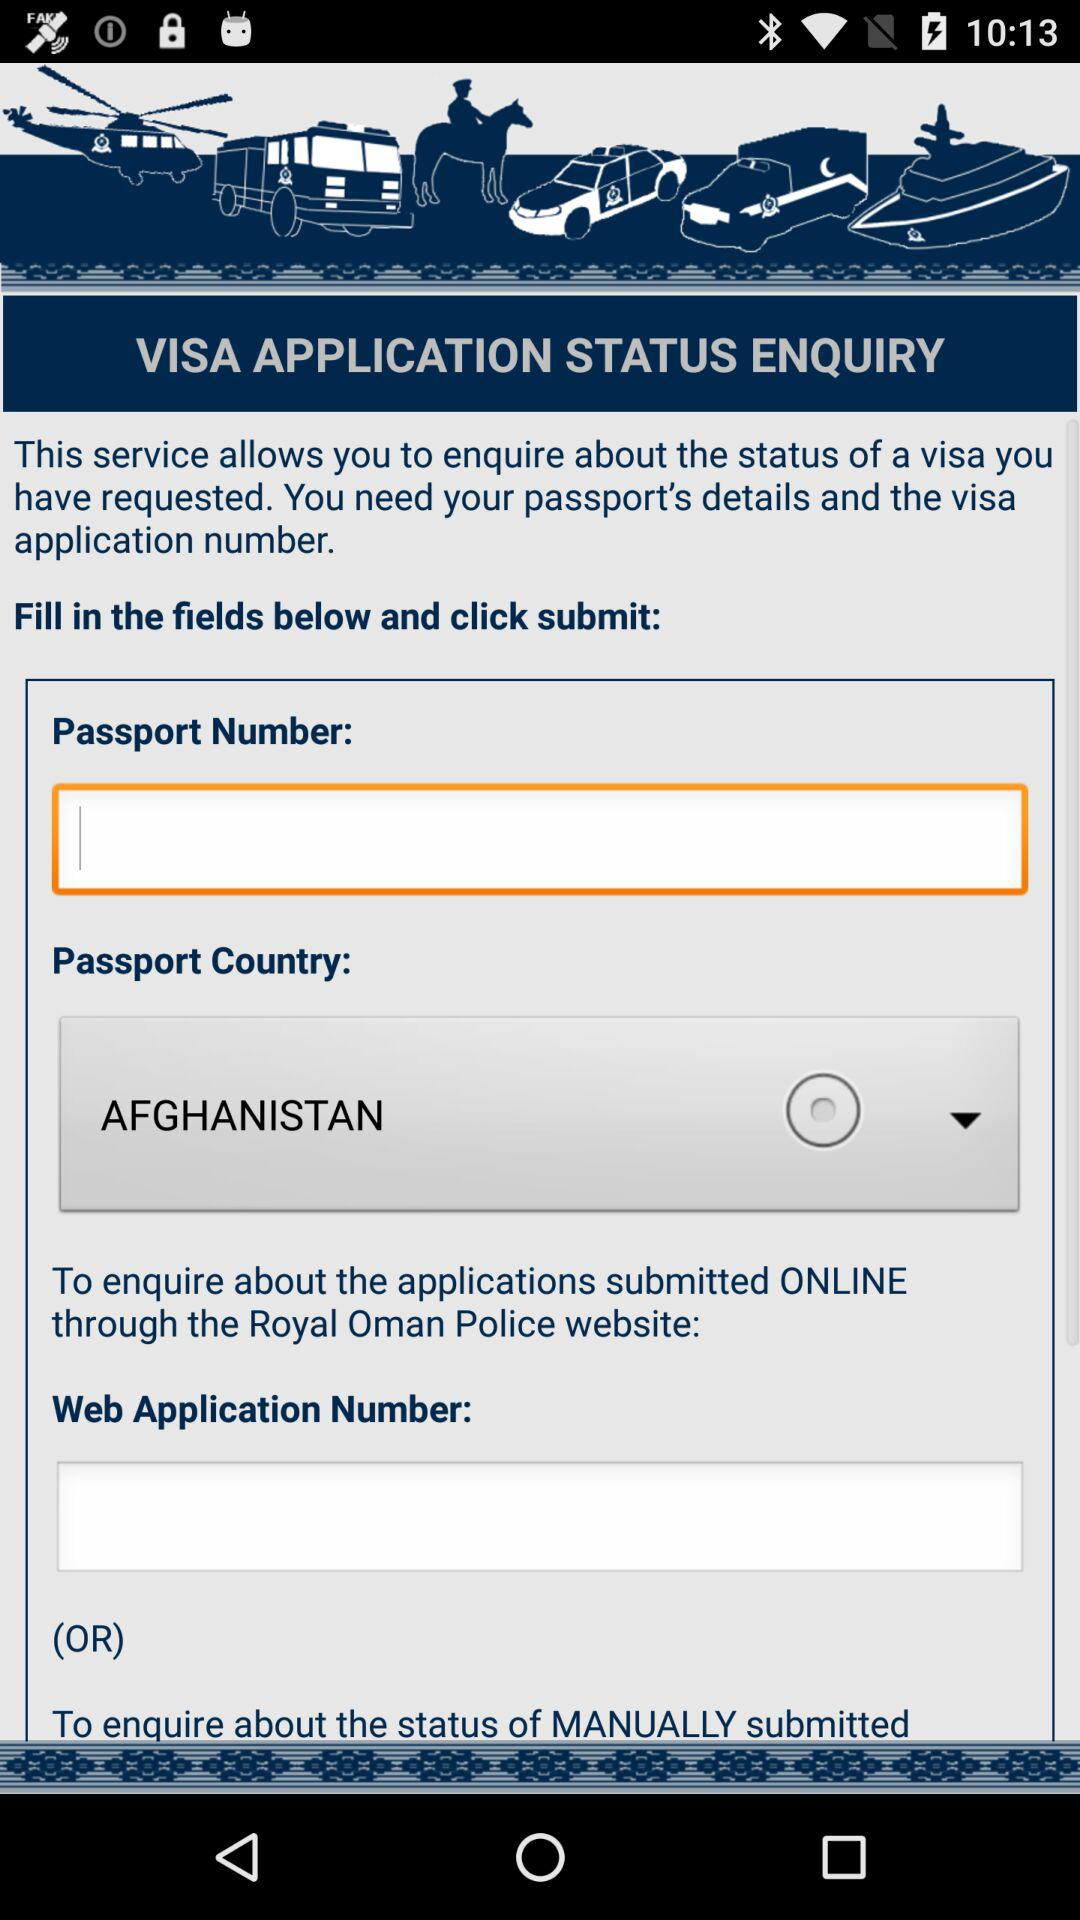How many input fields are there for the web application number?
Answer the question using a single word or phrase. 1 